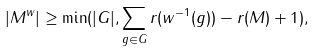Convert formula to latex. <formula><loc_0><loc_0><loc_500><loc_500>| M ^ { w } | \geq \min ( | G | , \sum _ { g \in G } r ( w ^ { - 1 } ( g ) ) - r ( M ) + 1 ) ,</formula> 